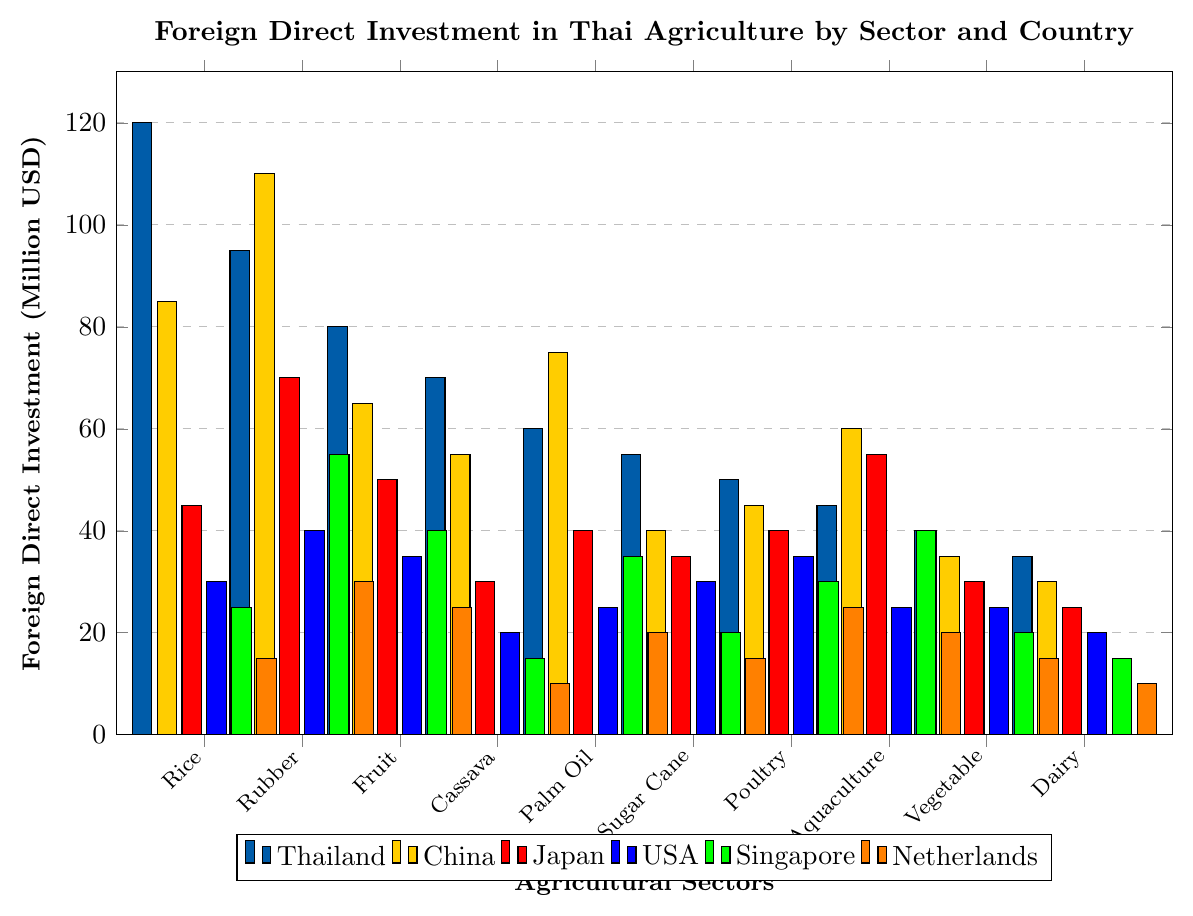Which sector receives the highest foreign direct investment from Thailand? The highest bar for Thailand is in the "Rice Farming" sector, indicating it receives the most investment from Thailand.
Answer: Rice Farming Compare the foreign direct investment in rubber plantations from China and Japan. Which is higher? The bar for China is taller than the bar for Japan in the "Rubber Plantations" sector.
Answer: China What is the total foreign direct investment in aquaculture across all countries? Sum the investment for each country in aquaculture: Thailand (45) + China (60) + Japan (55) + USA (25) + Singapore (40) + Netherlands (20). 45 + 60 + 55 + 25 + 40 + 20 = 245.
Answer: 245 Which sector has the smallest amount of foreign direct investment from the USA? The shortest bar for the USA is in the "Cassava Production" sector.
Answer: Cassava Production How does the foreign direct investment from Singapore in fruit orchards compare to vegetable farming? The bar representing "Fruit Orchards" for Singapore is taller than the bar for "Vegetable Farming".
Answer: Greater in Fruit Orchards What is the difference in foreign direct investment from the Netherlands in palm oil cultivation and rice farming? Subtract the investment in rice farming (15) from palm oil cultivation (20). 20 - 15 = 5.
Answer: 5 What colors represent Thailand and the Netherlands in the plot? The color bars representing Thailand are a type of blue, whereas the Netherlands are represented with a color resembling orange.
Answer: Blue for Thailand, Orange for Netherlands What is the average foreign direct investment from Japan in rice farming, poultry farming, and dairy farming? Sum the investments and divide by the number of sectors: (45 + 40 + 25) / 3. (45 + 40 + 25) = 110, 110 / 3 ≈ 36.67.
Answer: 36.67 Compare the foreign direct investments from the USA and Singapore in sugar cane farming. Which one is higher? The investment from the USA and Singapore in sugar cane farming are equal.
Answer: Equal In which sector does China invest more than Thailand but less than Japan? Look for sectors where the bar for China is taller than that for Thailand but shorter than that for Japan. "Aquaculture" fits this condition.
Answer: Aquaculture 